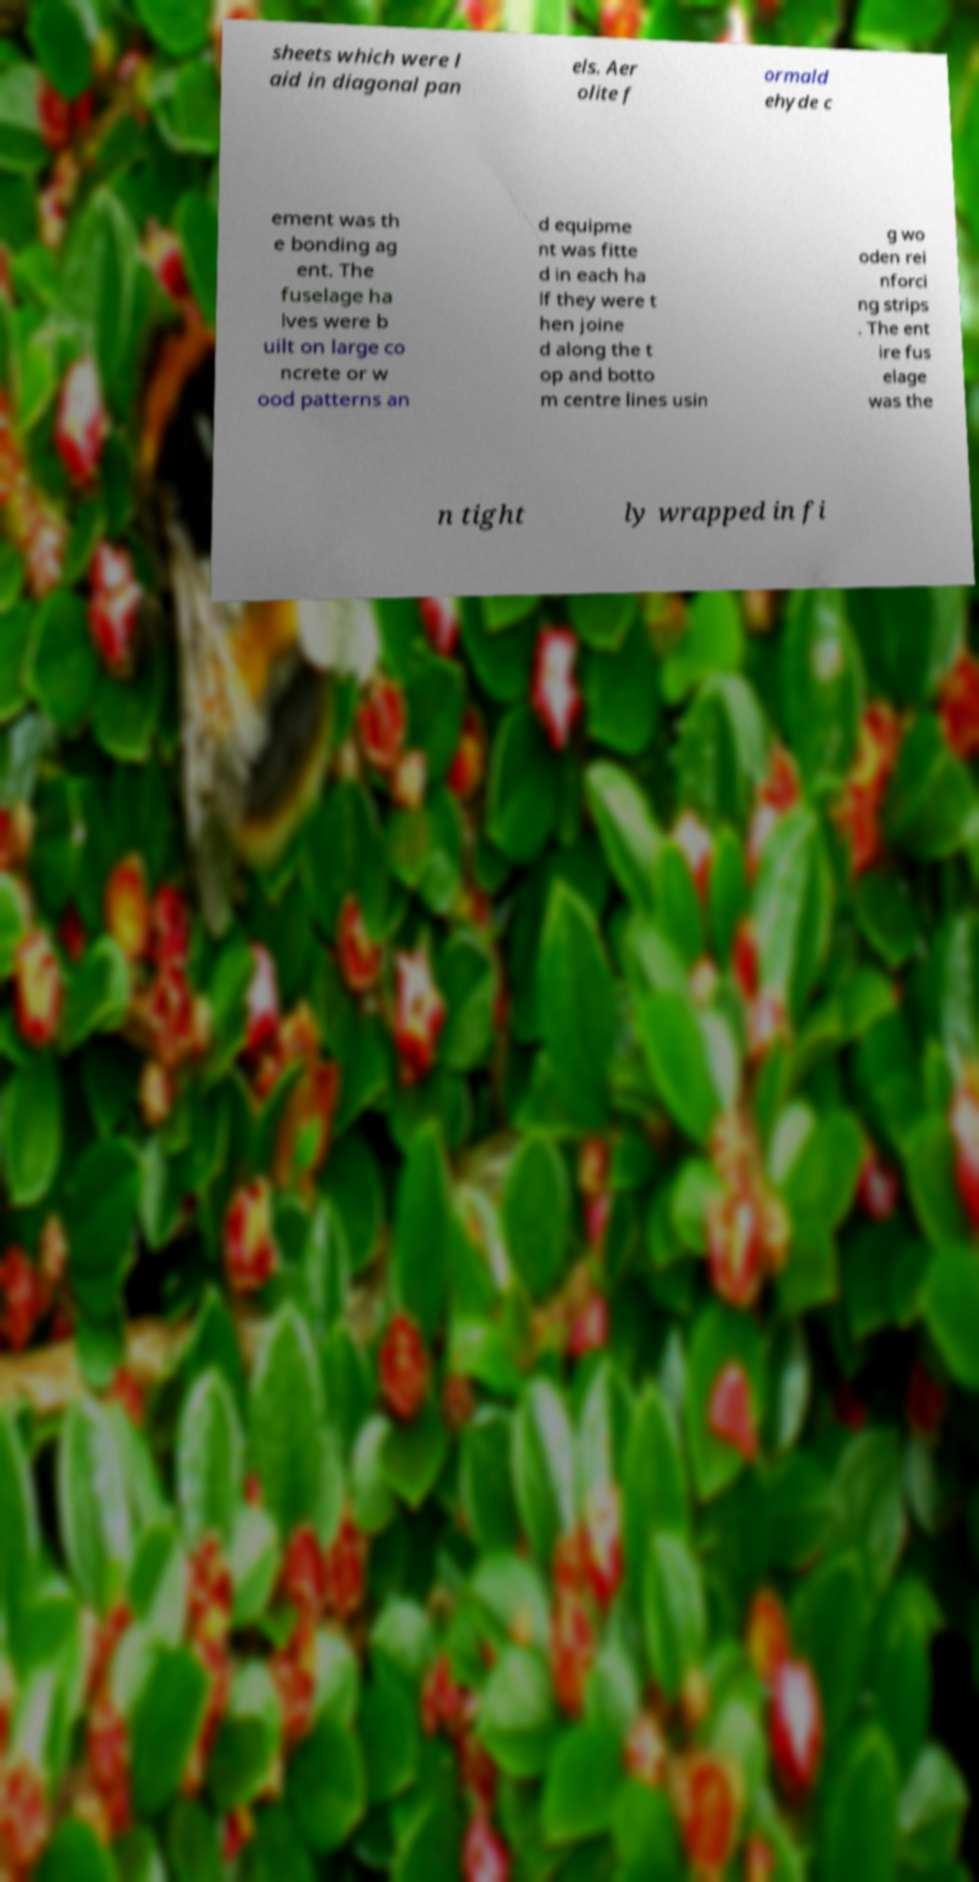Please read and relay the text visible in this image. What does it say? sheets which were l aid in diagonal pan els. Aer olite f ormald ehyde c ement was th e bonding ag ent. The fuselage ha lves were b uilt on large co ncrete or w ood patterns an d equipme nt was fitte d in each ha lf they were t hen joine d along the t op and botto m centre lines usin g wo oden rei nforci ng strips . The ent ire fus elage was the n tight ly wrapped in fi 